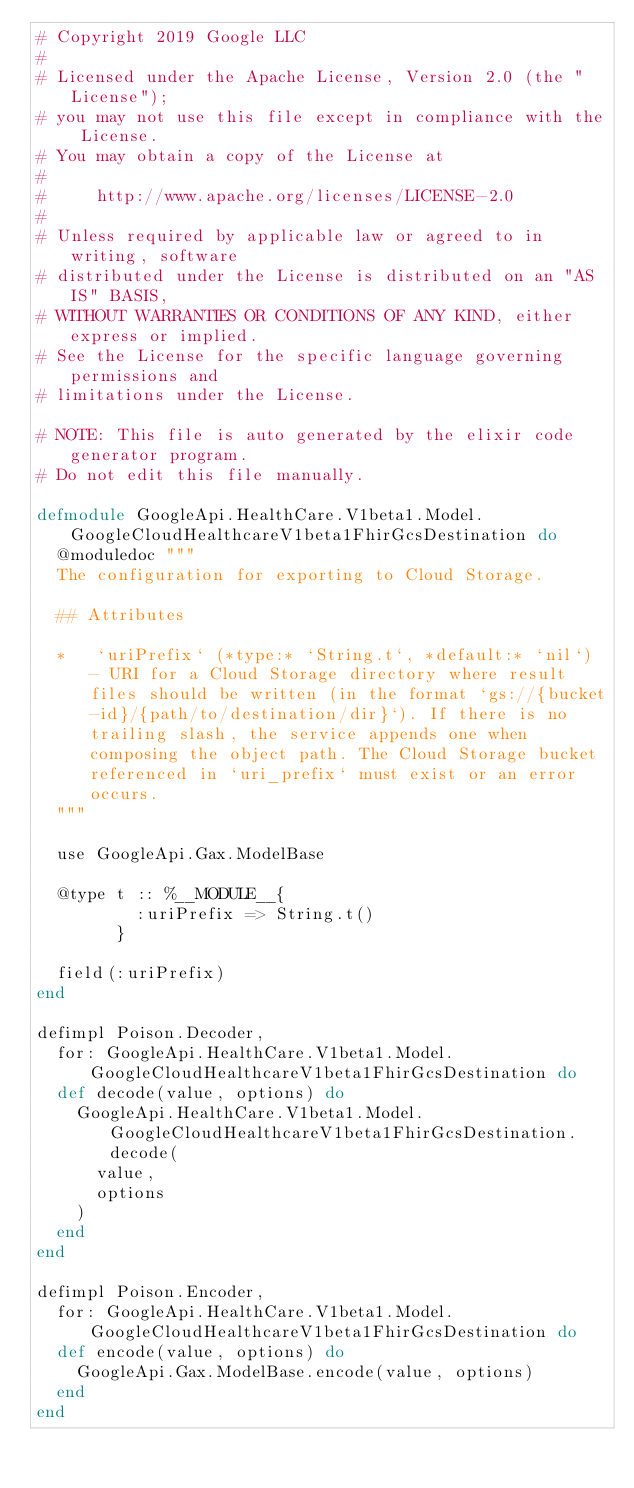Convert code to text. <code><loc_0><loc_0><loc_500><loc_500><_Elixir_># Copyright 2019 Google LLC
#
# Licensed under the Apache License, Version 2.0 (the "License");
# you may not use this file except in compliance with the License.
# You may obtain a copy of the License at
#
#     http://www.apache.org/licenses/LICENSE-2.0
#
# Unless required by applicable law or agreed to in writing, software
# distributed under the License is distributed on an "AS IS" BASIS,
# WITHOUT WARRANTIES OR CONDITIONS OF ANY KIND, either express or implied.
# See the License for the specific language governing permissions and
# limitations under the License.

# NOTE: This file is auto generated by the elixir code generator program.
# Do not edit this file manually.

defmodule GoogleApi.HealthCare.V1beta1.Model.GoogleCloudHealthcareV1beta1FhirGcsDestination do
  @moduledoc """
  The configuration for exporting to Cloud Storage.

  ## Attributes

  *   `uriPrefix` (*type:* `String.t`, *default:* `nil`) - URI for a Cloud Storage directory where result files should be written (in the format `gs://{bucket-id}/{path/to/destination/dir}`). If there is no trailing slash, the service appends one when composing the object path. The Cloud Storage bucket referenced in `uri_prefix` must exist or an error occurs.
  """

  use GoogleApi.Gax.ModelBase

  @type t :: %__MODULE__{
          :uriPrefix => String.t()
        }

  field(:uriPrefix)
end

defimpl Poison.Decoder,
  for: GoogleApi.HealthCare.V1beta1.Model.GoogleCloudHealthcareV1beta1FhirGcsDestination do
  def decode(value, options) do
    GoogleApi.HealthCare.V1beta1.Model.GoogleCloudHealthcareV1beta1FhirGcsDestination.decode(
      value,
      options
    )
  end
end

defimpl Poison.Encoder,
  for: GoogleApi.HealthCare.V1beta1.Model.GoogleCloudHealthcareV1beta1FhirGcsDestination do
  def encode(value, options) do
    GoogleApi.Gax.ModelBase.encode(value, options)
  end
end
</code> 